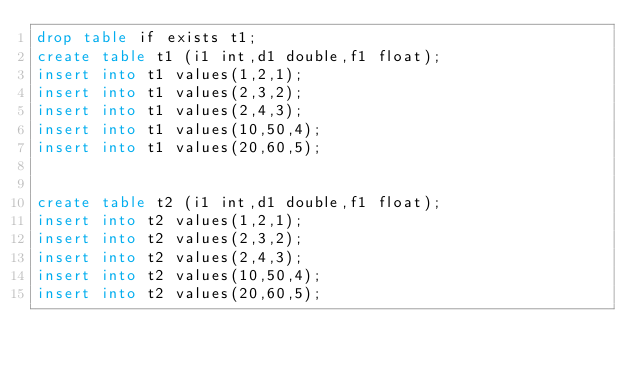<code> <loc_0><loc_0><loc_500><loc_500><_SQL_>drop table if exists t1;
create table t1 (i1 int,d1 double,f1 float);
insert into t1 values(1,2,1);
insert into t1 values(2,3,2);
insert into t1 values(2,4,3);
insert into t1 values(10,50,4);
insert into t1 values(20,60,5);


create table t2 (i1 int,d1 double,f1 float);
insert into t2 values(1,2,1);
insert into t2 values(2,3,2);
insert into t2 values(2,4,3);
insert into t2 values(10,50,4);
insert into t2 values(20,60,5);
</code> 